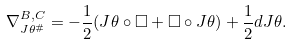<formula> <loc_0><loc_0><loc_500><loc_500>\nabla ^ { B , C } _ { J \theta ^ { \# } } = - \frac { 1 } { 2 } ( J \theta \circ \Box + \Box \circ J \theta ) + \frac { 1 } { 2 } d J \theta .</formula> 